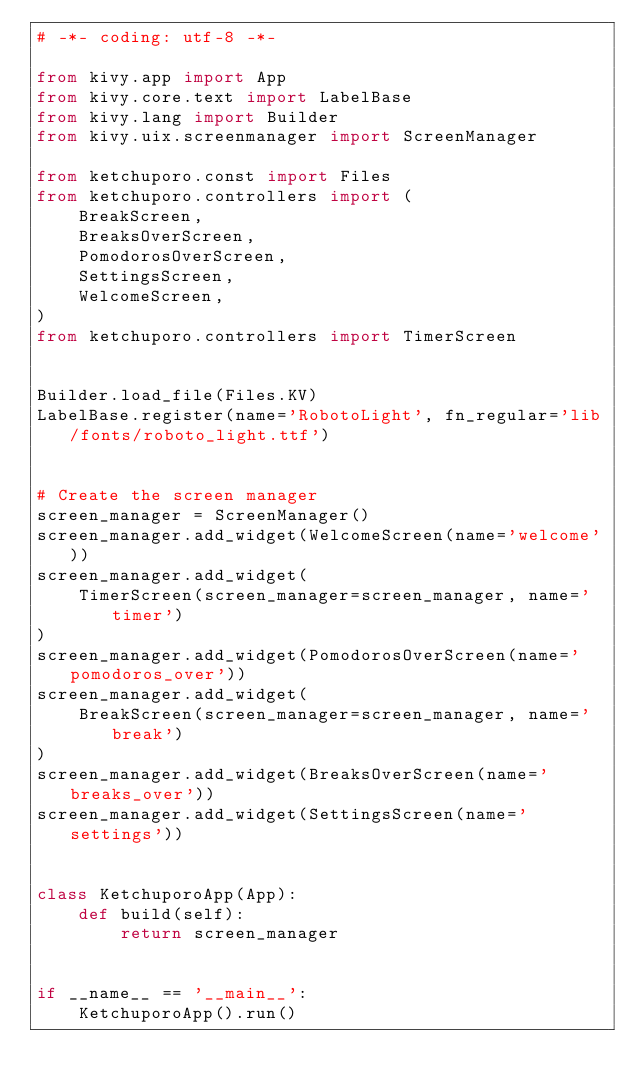Convert code to text. <code><loc_0><loc_0><loc_500><loc_500><_Python_># -*- coding: utf-8 -*-

from kivy.app import App
from kivy.core.text import LabelBase
from kivy.lang import Builder
from kivy.uix.screenmanager import ScreenManager

from ketchuporo.const import Files
from ketchuporo.controllers import (
    BreakScreen,
    BreaksOverScreen,
    PomodorosOverScreen,
    SettingsScreen,
    WelcomeScreen,
)
from ketchuporo.controllers import TimerScreen


Builder.load_file(Files.KV)
LabelBase.register(name='RobotoLight', fn_regular='lib/fonts/roboto_light.ttf')


# Create the screen manager
screen_manager = ScreenManager()
screen_manager.add_widget(WelcomeScreen(name='welcome'))
screen_manager.add_widget(
    TimerScreen(screen_manager=screen_manager, name='timer')
)
screen_manager.add_widget(PomodorosOverScreen(name='pomodoros_over'))
screen_manager.add_widget(
    BreakScreen(screen_manager=screen_manager, name='break')
)
screen_manager.add_widget(BreaksOverScreen(name='breaks_over'))
screen_manager.add_widget(SettingsScreen(name='settings'))


class KetchuporoApp(App):
    def build(self):
        return screen_manager


if __name__ == '__main__':
    KetchuporoApp().run()
</code> 